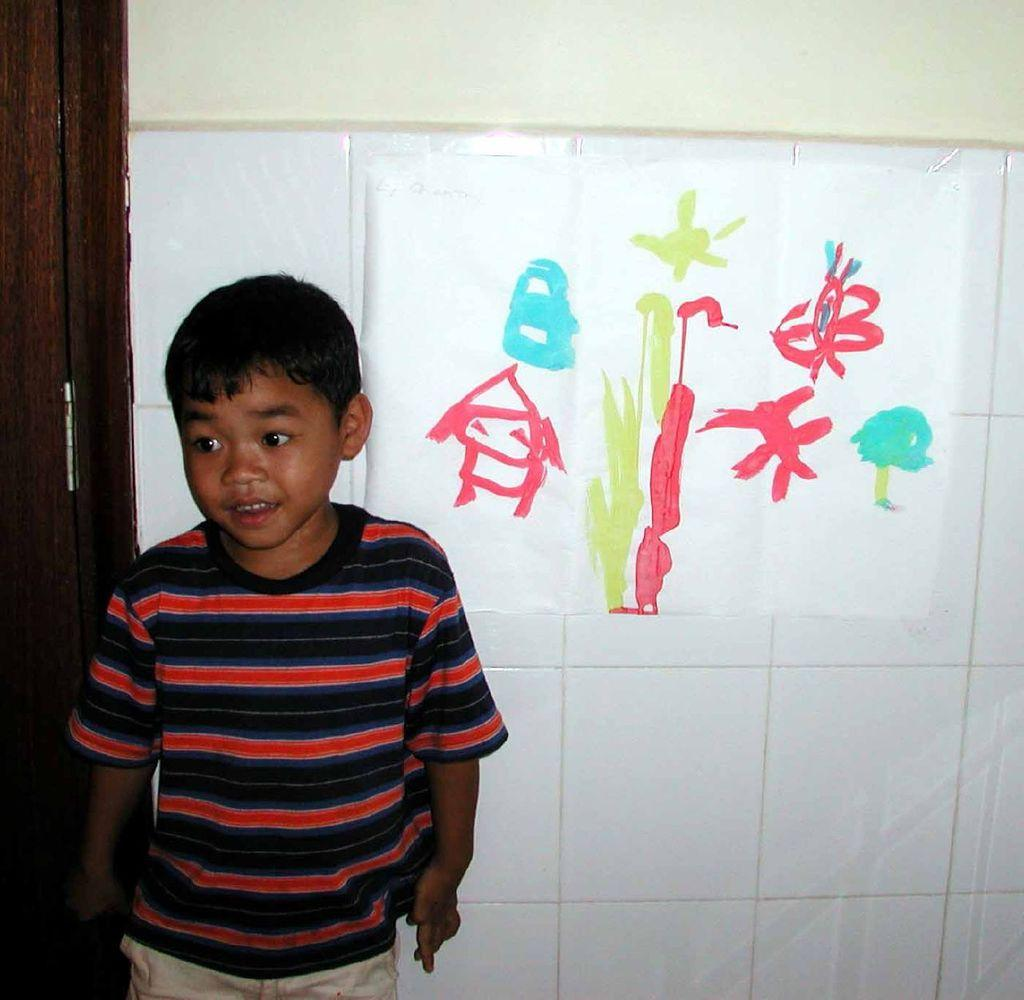What is the main subject of the image? There is a boy standing in the center of the image. What can be seen in the background of the image? There is a wall, paper, and wood in the background of the image. What is depicted on the paper in the image? There is a painting on the paper. What type of bat is flying in the image? There is no bat present in the image. What year does the painting on the paper depict? The provided facts do not mention any specific year or time period related to the painting. 